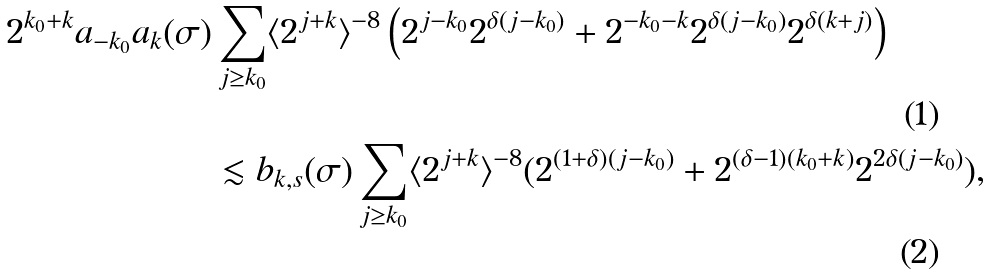<formula> <loc_0><loc_0><loc_500><loc_500>2 ^ { k _ { 0 } + k } a _ { - k _ { 0 } } a _ { k } ( \sigma ) & \sum _ { j \geq k _ { 0 } } \langle 2 ^ { j + k } \rangle ^ { - 8 } \left ( 2 ^ { j - k _ { 0 } } 2 ^ { \delta ( j - k _ { 0 } ) } + 2 ^ { - k _ { 0 } - k } 2 ^ { \delta ( j - k _ { 0 } ) } 2 ^ { \delta ( k + j ) } \right ) \\ & \lesssim b _ { k , s } ( \sigma ) \sum _ { j \geq k _ { 0 } } \langle 2 ^ { j + k } \rangle ^ { - 8 } ( 2 ^ { ( 1 + \delta ) ( j - k _ { 0 } ) } + 2 ^ { ( \delta - 1 ) ( k _ { 0 } + k ) } 2 ^ { 2 \delta ( j - k _ { 0 } ) } ) ,</formula> 